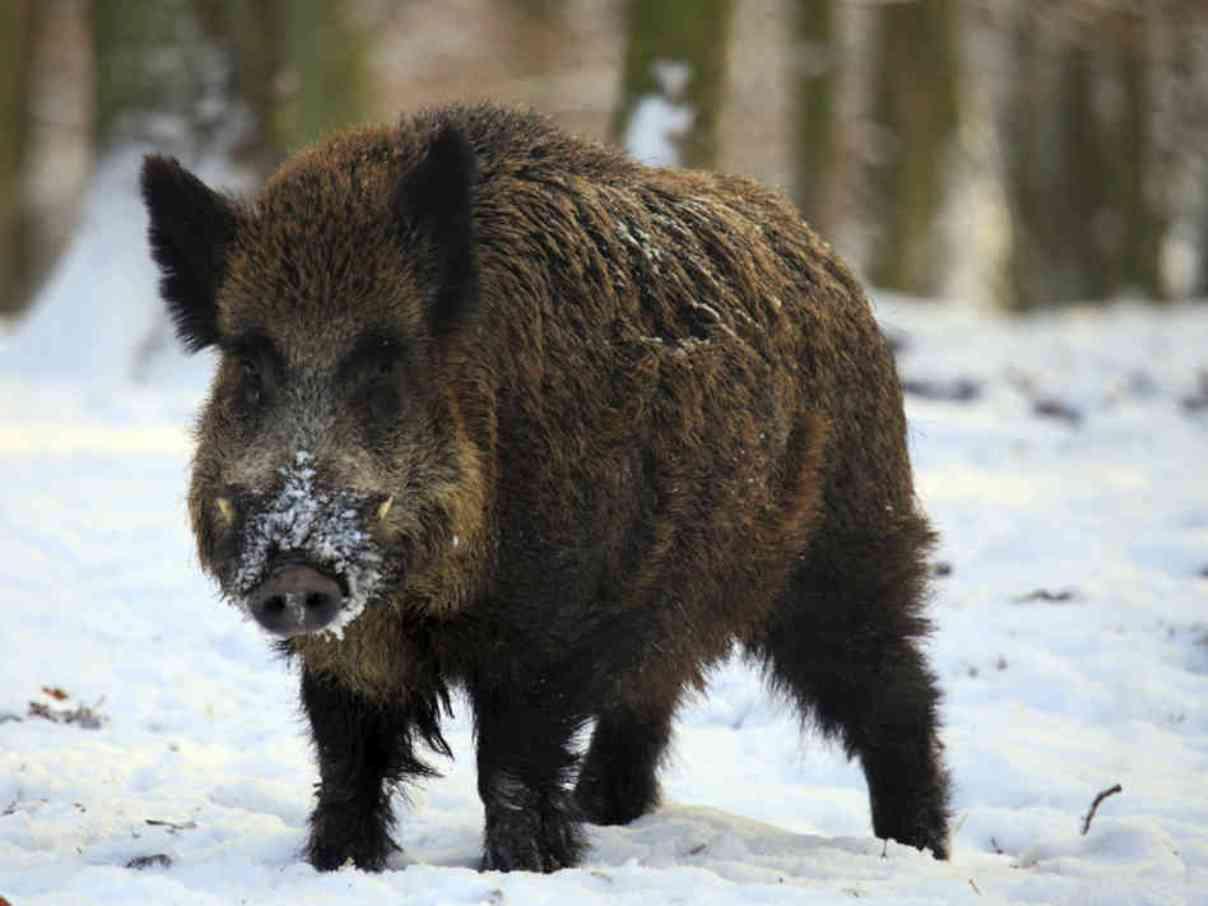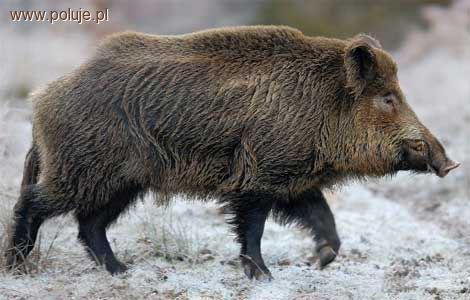The first image is the image on the left, the second image is the image on the right. Assess this claim about the two images: "One of the wild pigs is standing in profile, and the other pig is standing with its snout aimed forward.". Correct or not? Answer yes or no. Yes. The first image is the image on the left, the second image is the image on the right. Assess this claim about the two images: "A pig is walking in the snow.". Correct or not? Answer yes or no. Yes. 